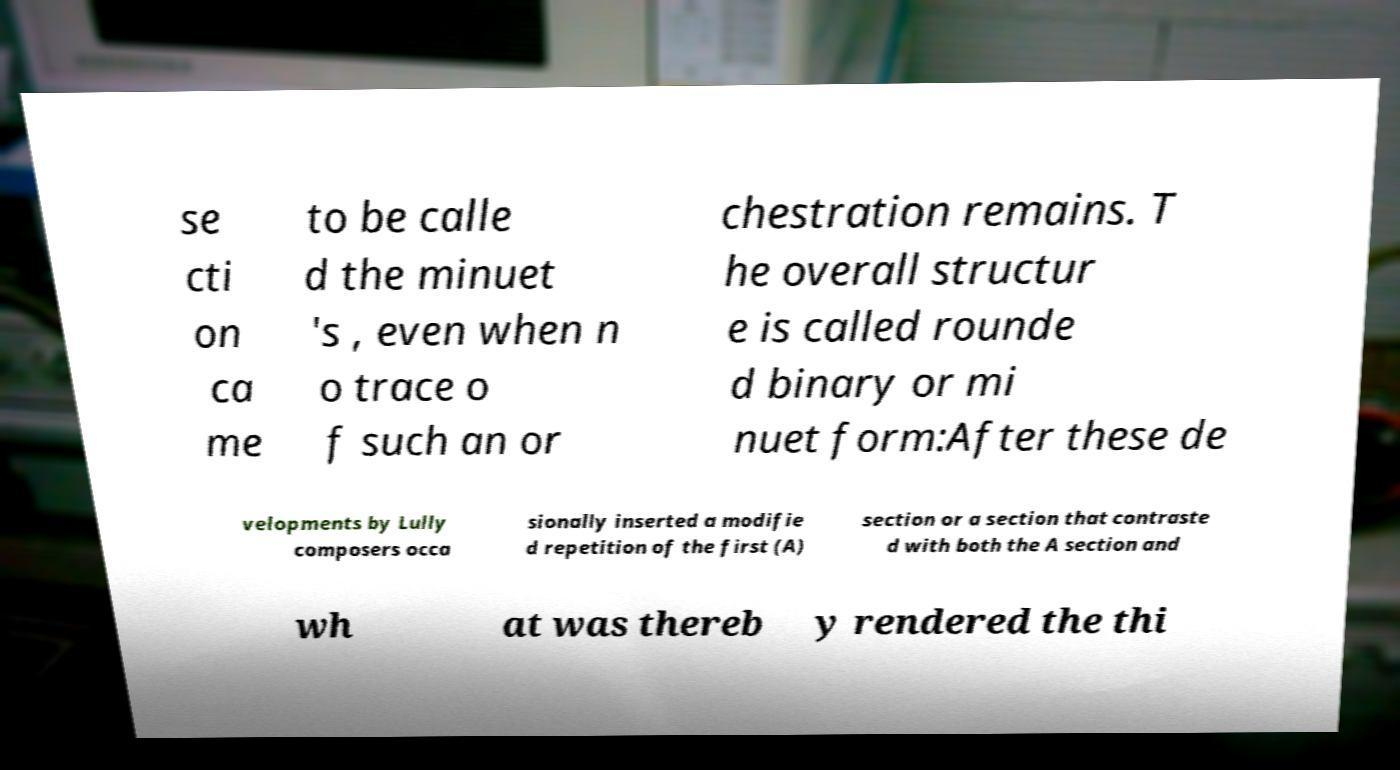Could you assist in decoding the text presented in this image and type it out clearly? se cti on ca me to be calle d the minuet 's , even when n o trace o f such an or chestration remains. T he overall structur e is called rounde d binary or mi nuet form:After these de velopments by Lully composers occa sionally inserted a modifie d repetition of the first (A) section or a section that contraste d with both the A section and wh at was thereb y rendered the thi 